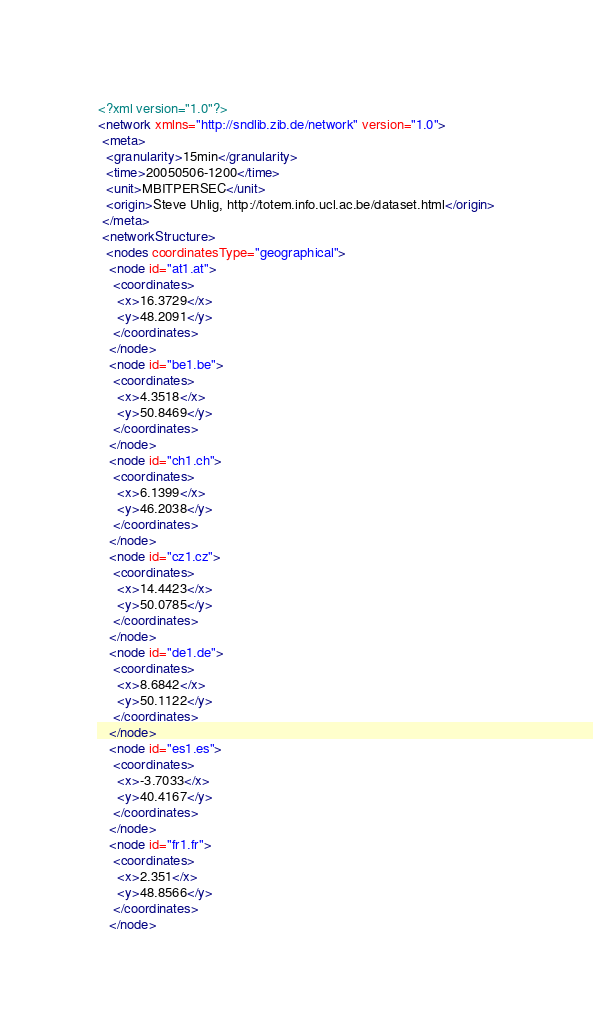<code> <loc_0><loc_0><loc_500><loc_500><_XML_><?xml version="1.0"?>
<network xmlns="http://sndlib.zib.de/network" version="1.0">
 <meta>
  <granularity>15min</granularity>
  <time>20050506-1200</time>
  <unit>MBITPERSEC</unit>
  <origin>Steve Uhlig, http://totem.info.ucl.ac.be/dataset.html</origin>
 </meta>
 <networkStructure>
  <nodes coordinatesType="geographical">
   <node id="at1.at">
    <coordinates>
     <x>16.3729</x>
     <y>48.2091</y>
    </coordinates>
   </node>
   <node id="be1.be">
    <coordinates>
     <x>4.3518</x>
     <y>50.8469</y>
    </coordinates>
   </node>
   <node id="ch1.ch">
    <coordinates>
     <x>6.1399</x>
     <y>46.2038</y>
    </coordinates>
   </node>
   <node id="cz1.cz">
    <coordinates>
     <x>14.4423</x>
     <y>50.0785</y>
    </coordinates>
   </node>
   <node id="de1.de">
    <coordinates>
     <x>8.6842</x>
     <y>50.1122</y>
    </coordinates>
   </node>
   <node id="es1.es">
    <coordinates>
     <x>-3.7033</x>
     <y>40.4167</y>
    </coordinates>
   </node>
   <node id="fr1.fr">
    <coordinates>
     <x>2.351</x>
     <y>48.8566</y>
    </coordinates>
   </node></code> 